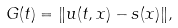Convert formula to latex. <formula><loc_0><loc_0><loc_500><loc_500>G ( t ) = \| u ( t , x ) - s ( x ) \| ,</formula> 